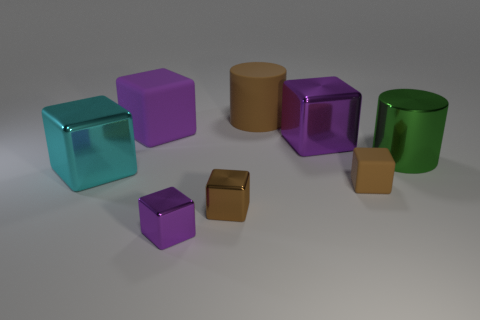Subtract all purple blocks. How many were subtracted if there are2purple blocks left? 1 Subtract all cyan blocks. How many blocks are left? 5 Add 1 big purple balls. How many objects exist? 9 Subtract 1 cubes. How many cubes are left? 5 Subtract all purple blocks. How many blocks are left? 3 Subtract all cubes. How many objects are left? 2 Add 5 large green metallic objects. How many large green metallic objects are left? 6 Add 2 large green things. How many large green things exist? 3 Subtract 1 brown cylinders. How many objects are left? 7 Subtract all cyan cylinders. Subtract all green blocks. How many cylinders are left? 2 